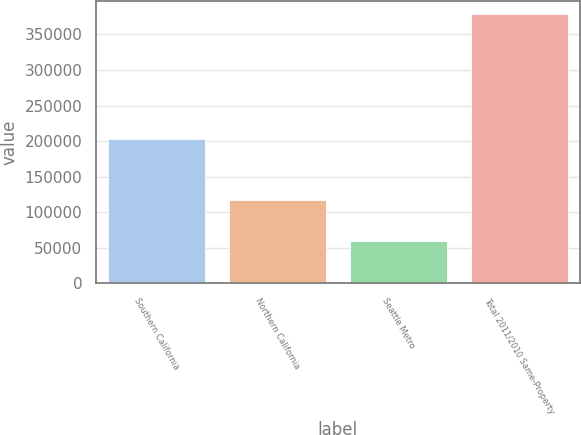<chart> <loc_0><loc_0><loc_500><loc_500><bar_chart><fcel>Southern California<fcel>Northern California<fcel>Seattle Metro<fcel>Total 2011/2010 Same-Property<nl><fcel>202354<fcel>116796<fcel>59101<fcel>378251<nl></chart> 